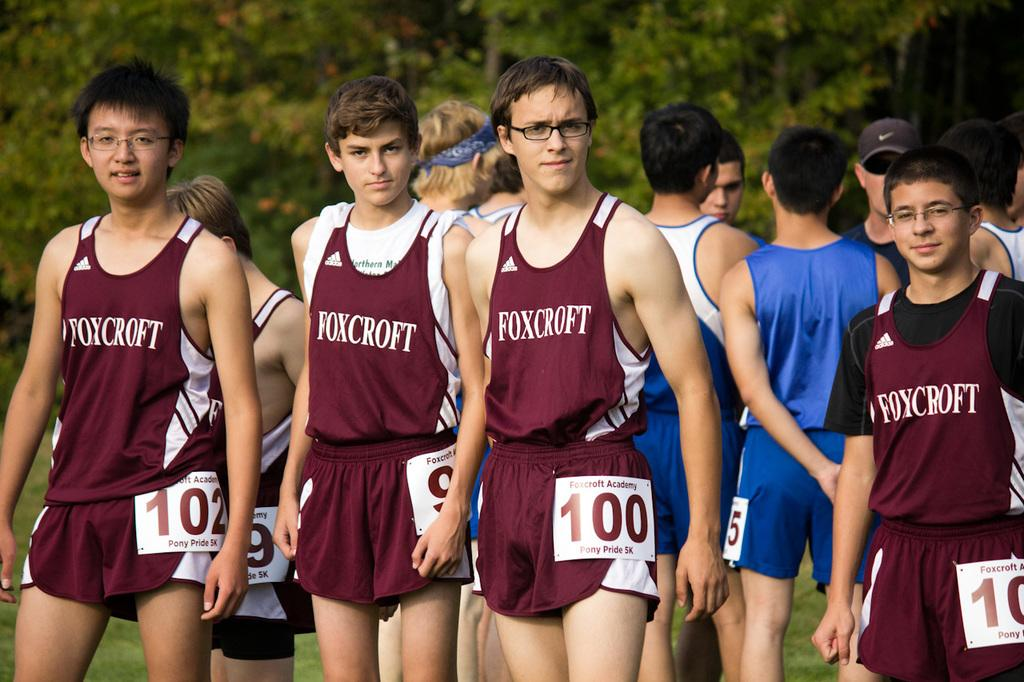<image>
Describe the image concisely. a foxcroft team that are standing near each other 